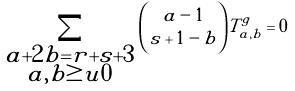<formula> <loc_0><loc_0><loc_500><loc_500>\sum _ { \substack { a + 2 b = r + s + 3 \\ a , b \geq u 0 } } \binom { a - 1 } { s + 1 - b } T ^ { g } _ { a , b } = 0</formula> 